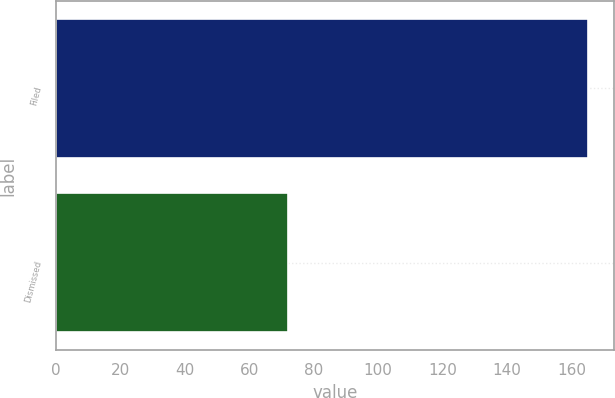Convert chart to OTSL. <chart><loc_0><loc_0><loc_500><loc_500><bar_chart><fcel>Filed<fcel>Dismissed<nl><fcel>165<fcel>72<nl></chart> 